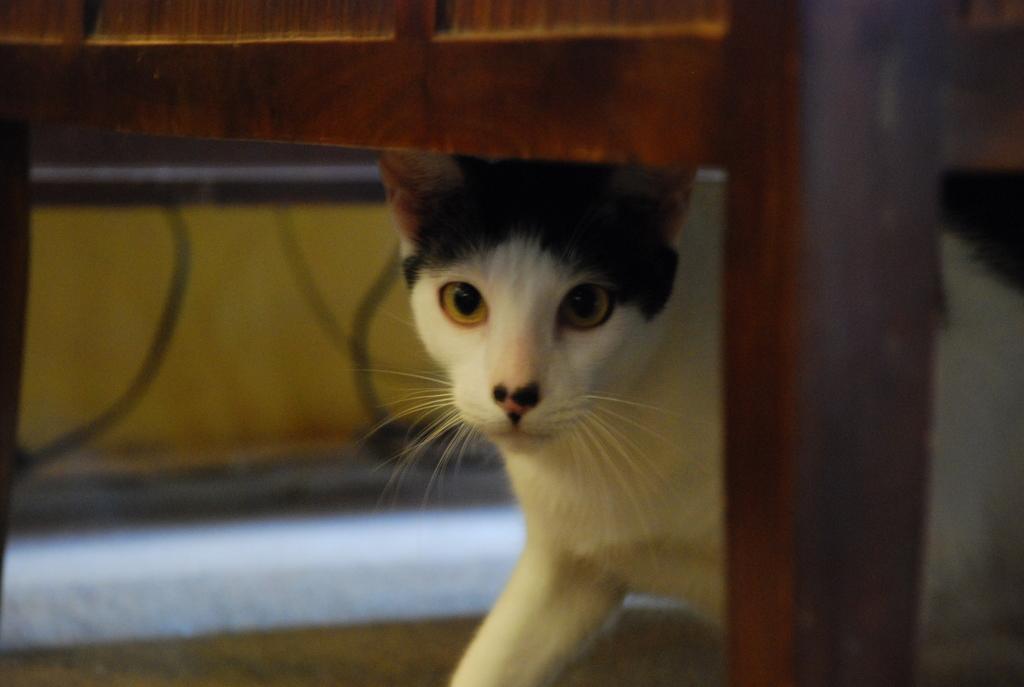Please provide a concise description of this image. In the picture we can see a wooden frame bench under it we can see a cat which is white in color with some black color part of its head. 